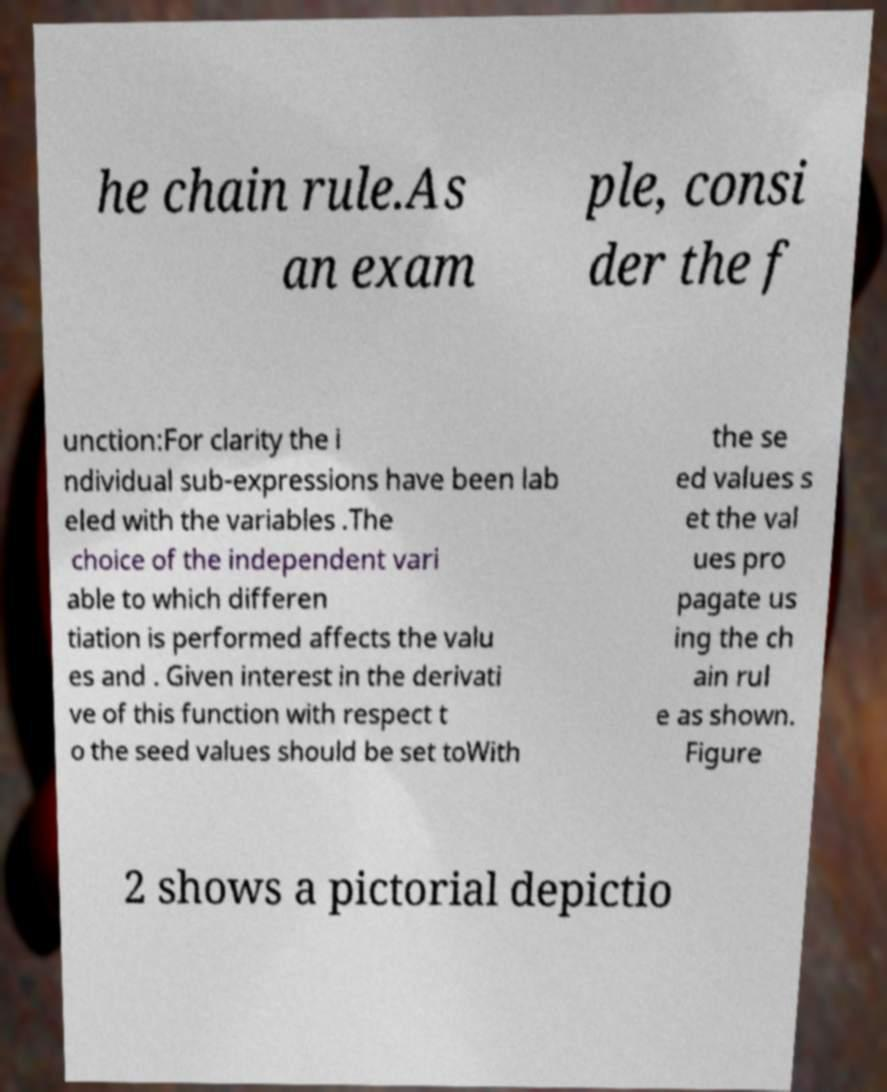Please identify and transcribe the text found in this image. he chain rule.As an exam ple, consi der the f unction:For clarity the i ndividual sub-expressions have been lab eled with the variables .The choice of the independent vari able to which differen tiation is performed affects the valu es and . Given interest in the derivati ve of this function with respect t o the seed values should be set toWith the se ed values s et the val ues pro pagate us ing the ch ain rul e as shown. Figure 2 shows a pictorial depictio 